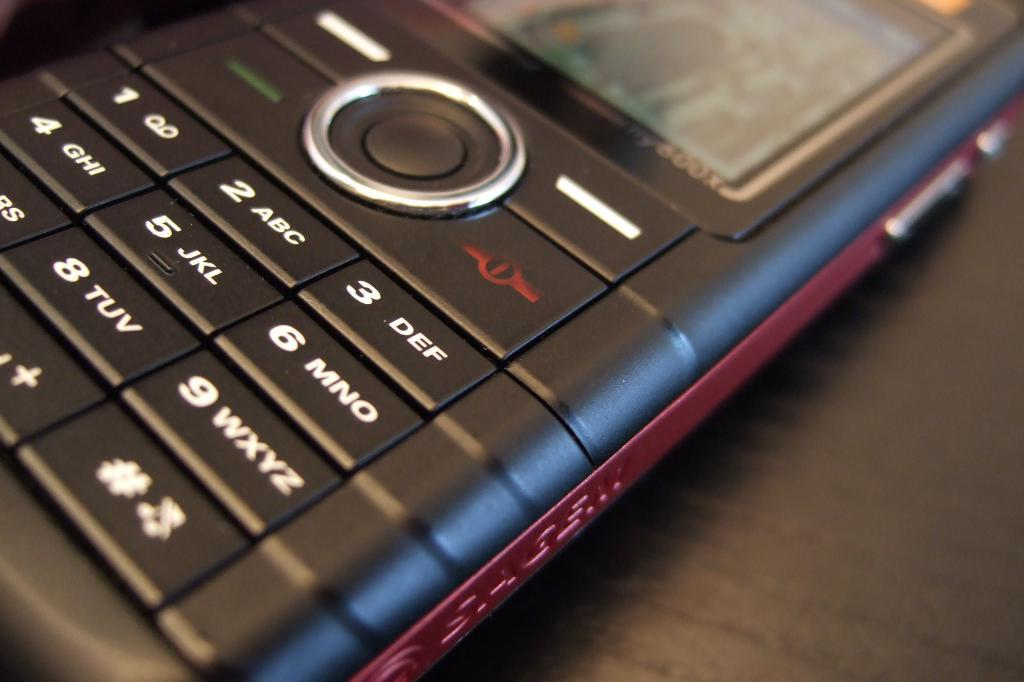<image>
Present a compact description of the photo's key features. an old style phone with the letters DEF beside the 3 on the keyboard 